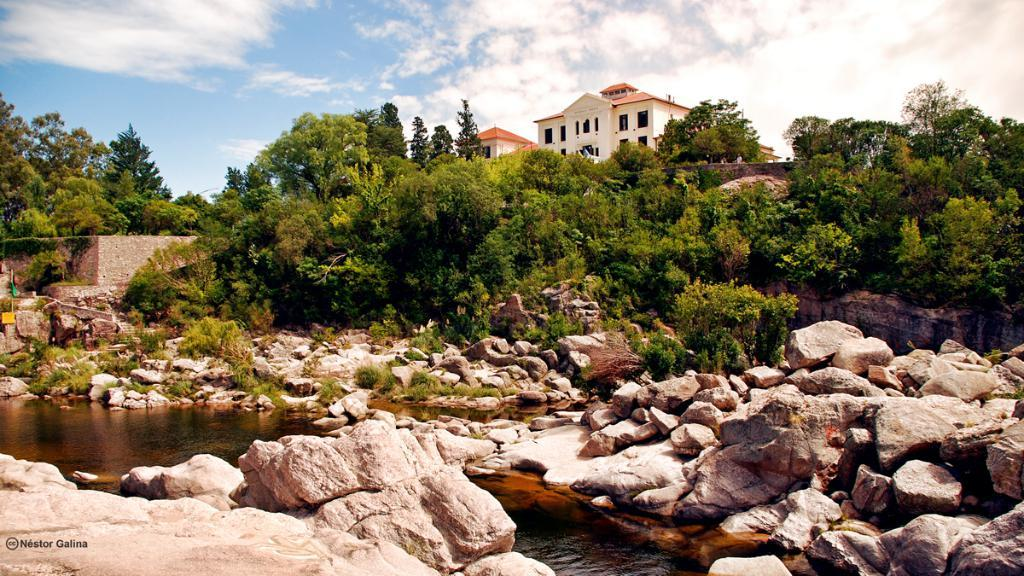What type of natural elements can be seen in the image? There are rocks, water, grass, and trees visible in the image. What type of structure can be seen in the background of the image? There is a building in the background of the image. What is visible in the sky in the image? The sky is visible in the background of the image. Can you hear the horn of the car in the image? There is no car or horn present in the image. How does the ear of the person in the image look like? There is no person or ear visible in the image. 